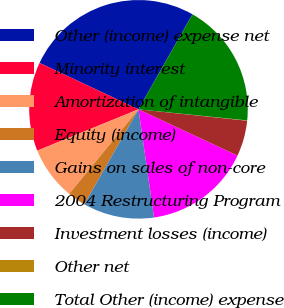Convert chart. <chart><loc_0><loc_0><loc_500><loc_500><pie_chart><fcel>Other (income) expense net<fcel>Minority interest<fcel>Amortization of intangible<fcel>Equity (income)<fcel>Gains on sales of non-core<fcel>2004 Restructuring Program<fcel>Investment losses (income)<fcel>Other net<fcel>Total Other (income) expense<nl><fcel>26.25%<fcel>13.15%<fcel>7.91%<fcel>2.67%<fcel>10.53%<fcel>15.77%<fcel>5.29%<fcel>0.05%<fcel>18.39%<nl></chart> 